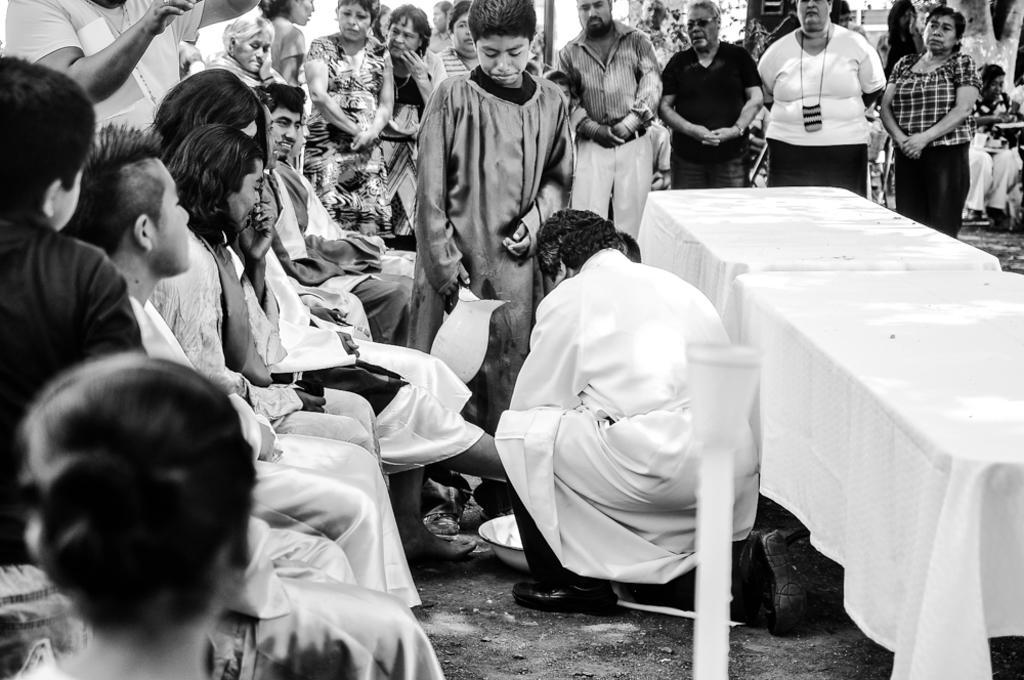Describe this image in one or two sentences. This is a black & white picture. Here we can see few persons sitting on chairs in front of a table and on the table there is a white cloth. Here we can see one man on the floor. Here we can see all the persons standing. on the background we can see few persons sitting. This is a branch. 